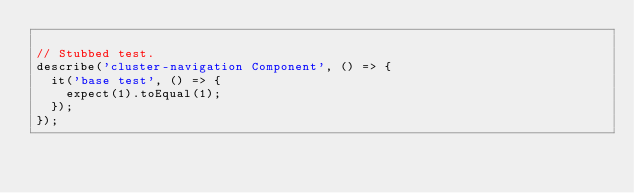<code> <loc_0><loc_0><loc_500><loc_500><_JavaScript_>
// Stubbed test.
describe('cluster-navigation Component', () => {
  it('base test', () => {
    expect(1).toEqual(1);
  });
});
</code> 